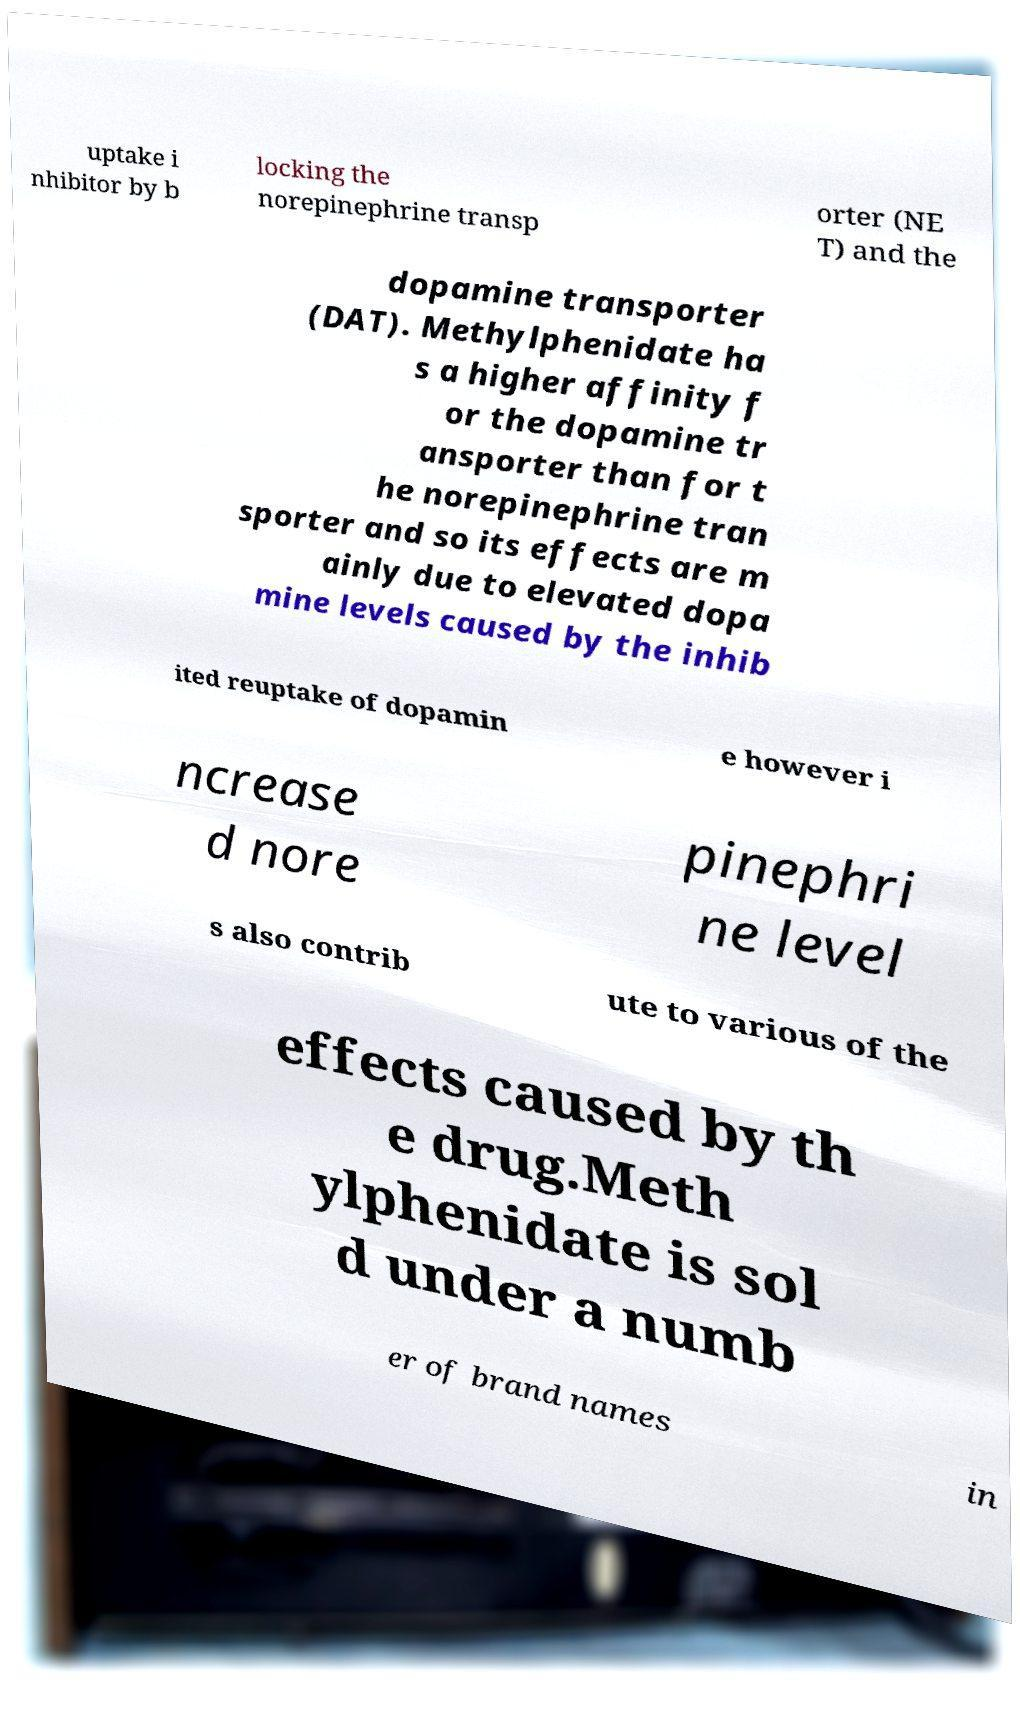Please read and relay the text visible in this image. What does it say? uptake i nhibitor by b locking the norepinephrine transp orter (NE T) and the dopamine transporter (DAT). Methylphenidate ha s a higher affinity f or the dopamine tr ansporter than for t he norepinephrine tran sporter and so its effects are m ainly due to elevated dopa mine levels caused by the inhib ited reuptake of dopamin e however i ncrease d nore pinephri ne level s also contrib ute to various of the effects caused by th e drug.Meth ylphenidate is sol d under a numb er of brand names in 